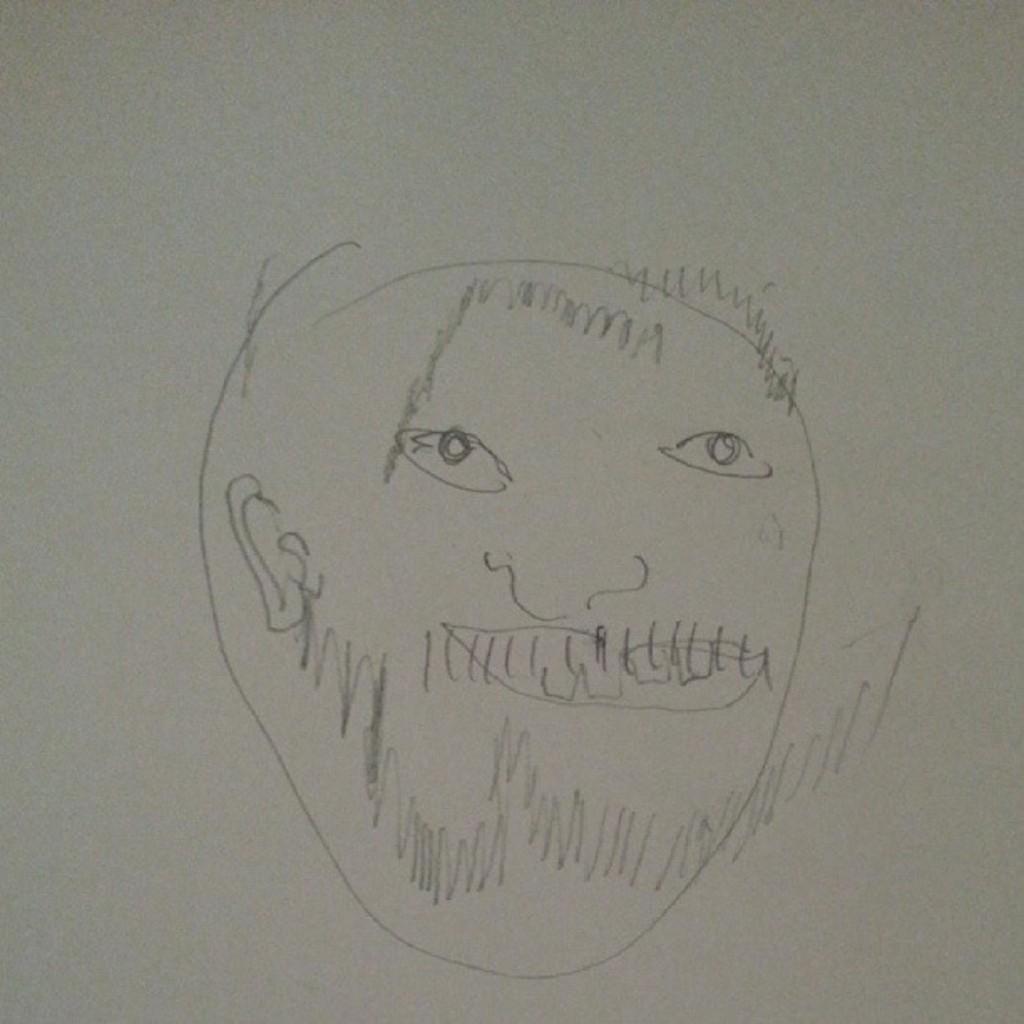Please provide a concise description of this image. In this image I can see a drawing is on the white surface.   